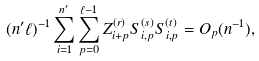Convert formula to latex. <formula><loc_0><loc_0><loc_500><loc_500>( n ^ { \prime } \ell ) ^ { - 1 } \sum _ { i = 1 } ^ { n ^ { \prime } } \sum _ { p = 0 } ^ { \ell - 1 } Z ^ { ( r ) } _ { i + p } S _ { i , p } ^ { ( s ) } S _ { i , p } ^ { ( t ) } = O _ { p } ( n ^ { - 1 } ) ,</formula> 